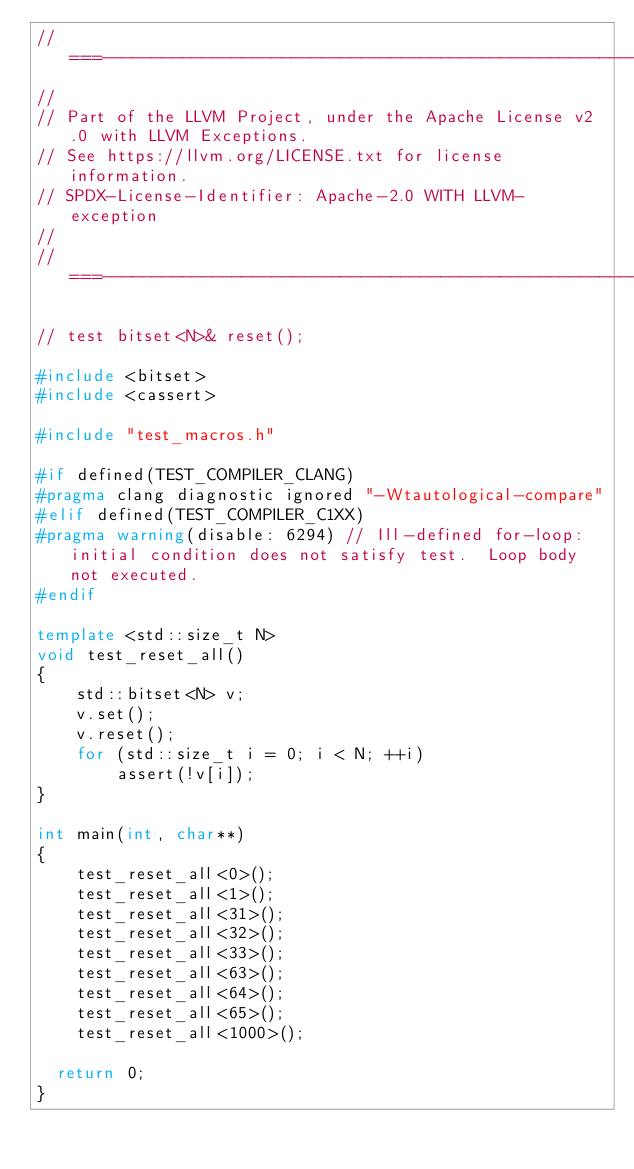<code> <loc_0><loc_0><loc_500><loc_500><_C++_>//===----------------------------------------------------------------------===//
//
// Part of the LLVM Project, under the Apache License v2.0 with LLVM Exceptions.
// See https://llvm.org/LICENSE.txt for license information.
// SPDX-License-Identifier: Apache-2.0 WITH LLVM-exception
//
//===----------------------------------------------------------------------===//

// test bitset<N>& reset();

#include <bitset>
#include <cassert>

#include "test_macros.h"

#if defined(TEST_COMPILER_CLANG)
#pragma clang diagnostic ignored "-Wtautological-compare"
#elif defined(TEST_COMPILER_C1XX)
#pragma warning(disable: 6294) // Ill-defined for-loop:  initial condition does not satisfy test.  Loop body not executed.
#endif

template <std::size_t N>
void test_reset_all()
{
    std::bitset<N> v;
    v.set();
    v.reset();
    for (std::size_t i = 0; i < N; ++i)
        assert(!v[i]);
}

int main(int, char**)
{
    test_reset_all<0>();
    test_reset_all<1>();
    test_reset_all<31>();
    test_reset_all<32>();
    test_reset_all<33>();
    test_reset_all<63>();
    test_reset_all<64>();
    test_reset_all<65>();
    test_reset_all<1000>();

  return 0;
}
</code> 